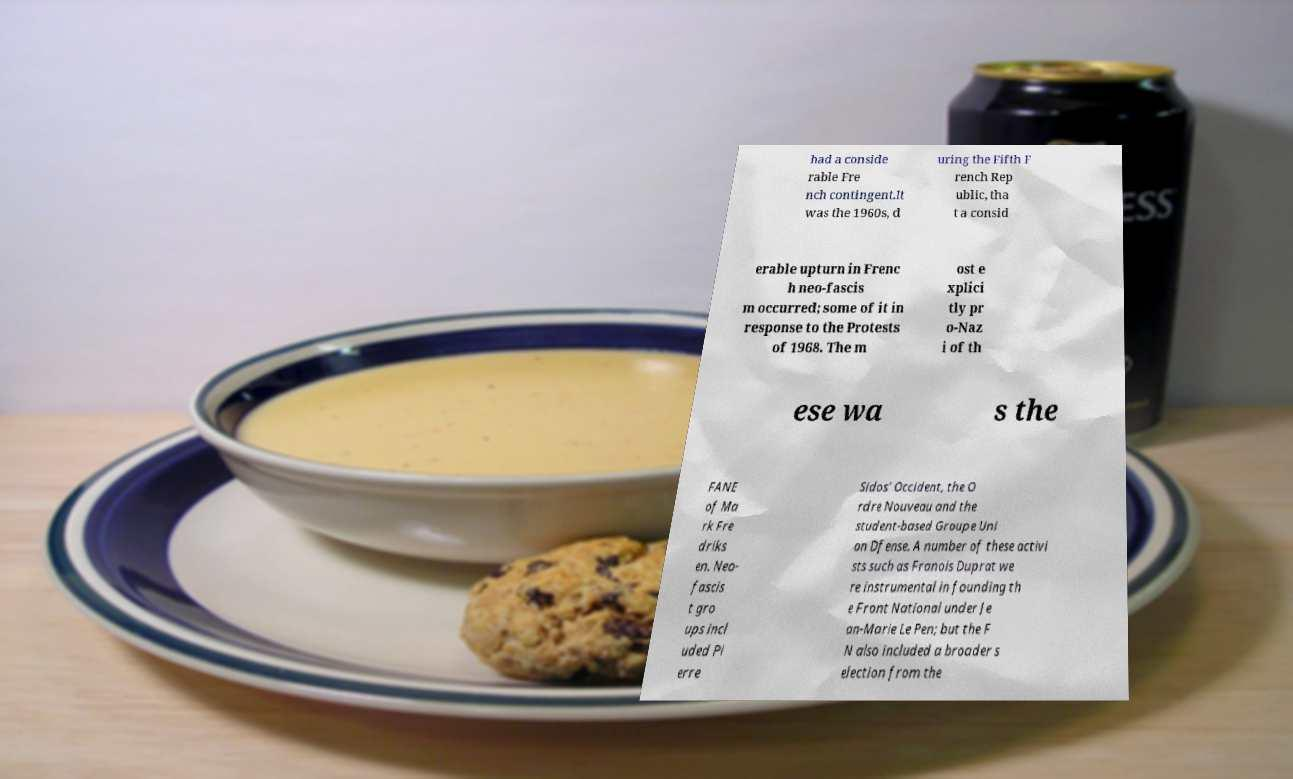What messages or text are displayed in this image? I need them in a readable, typed format. had a conside rable Fre nch contingent.It was the 1960s, d uring the Fifth F rench Rep ublic, tha t a consid erable upturn in Frenc h neo-fascis m occurred; some of it in response to the Protests of 1968. The m ost e xplici tly pr o-Naz i of th ese wa s the FANE of Ma rk Fre driks en. Neo- fascis t gro ups incl uded Pi erre Sidos' Occident, the O rdre Nouveau and the student-based Groupe Uni on Dfense. A number of these activi sts such as Franois Duprat we re instrumental in founding th e Front National under Je an-Marie Le Pen; but the F N also included a broader s election from the 